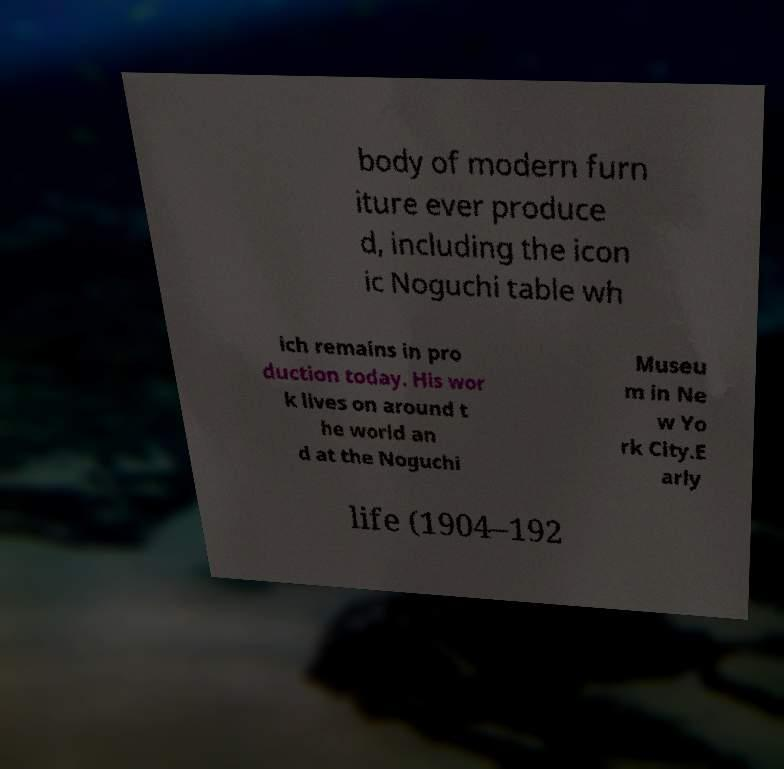For documentation purposes, I need the text within this image transcribed. Could you provide that? body of modern furn iture ever produce d, including the icon ic Noguchi table wh ich remains in pro duction today. His wor k lives on around t he world an d at the Noguchi Museu m in Ne w Yo rk City.E arly life (1904–192 